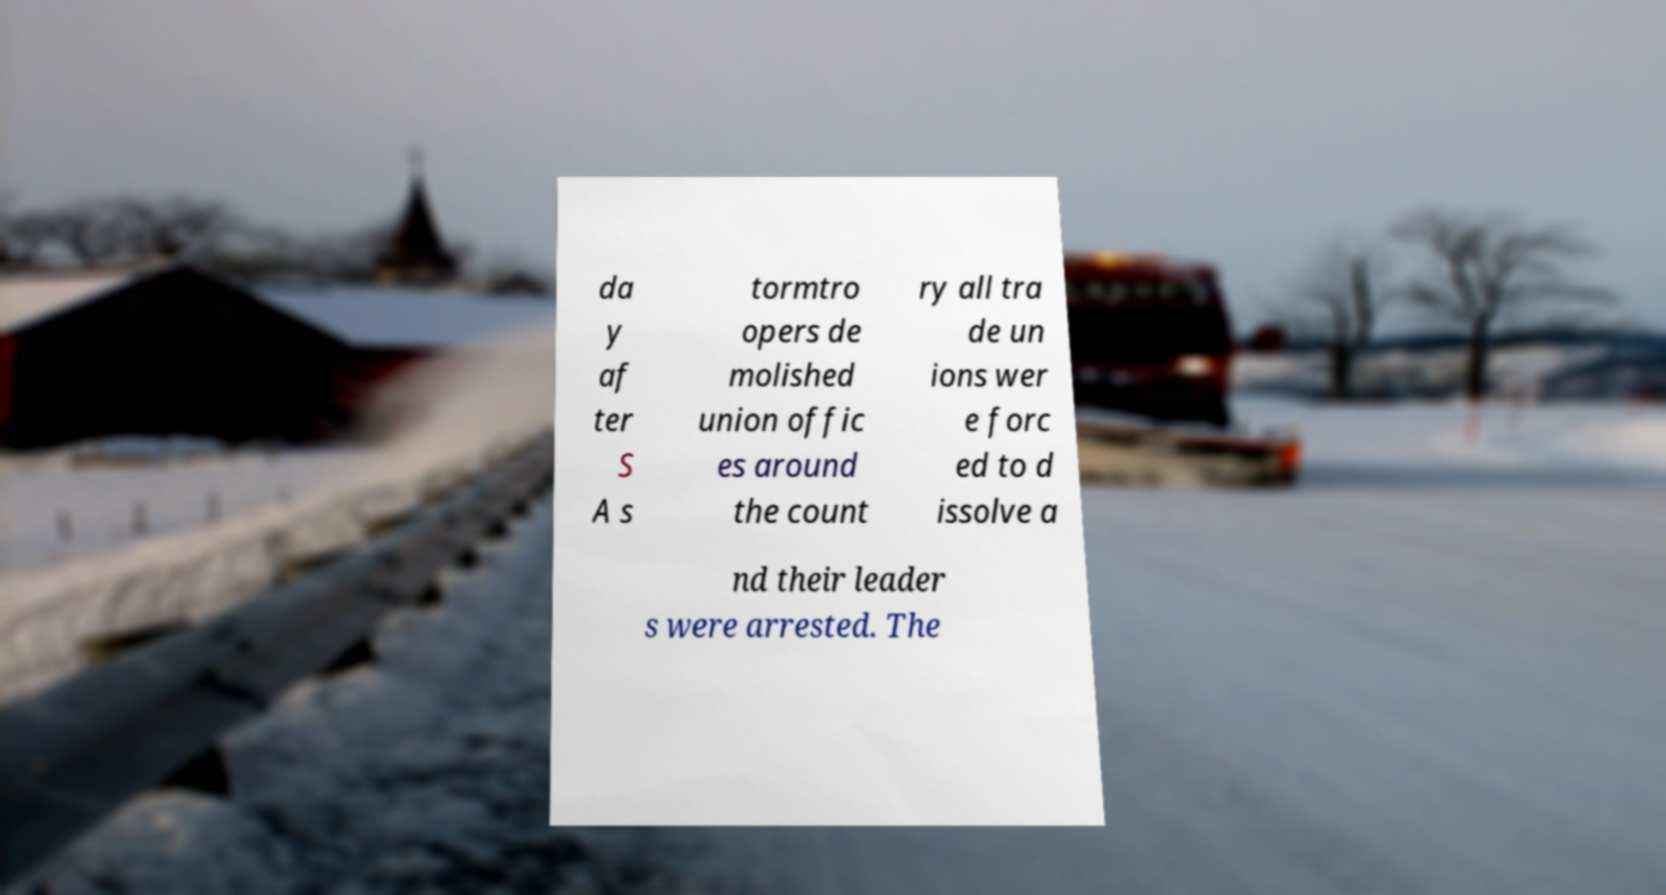Please identify and transcribe the text found in this image. da y af ter S A s tormtro opers de molished union offic es around the count ry all tra de un ions wer e forc ed to d issolve a nd their leader s were arrested. The 